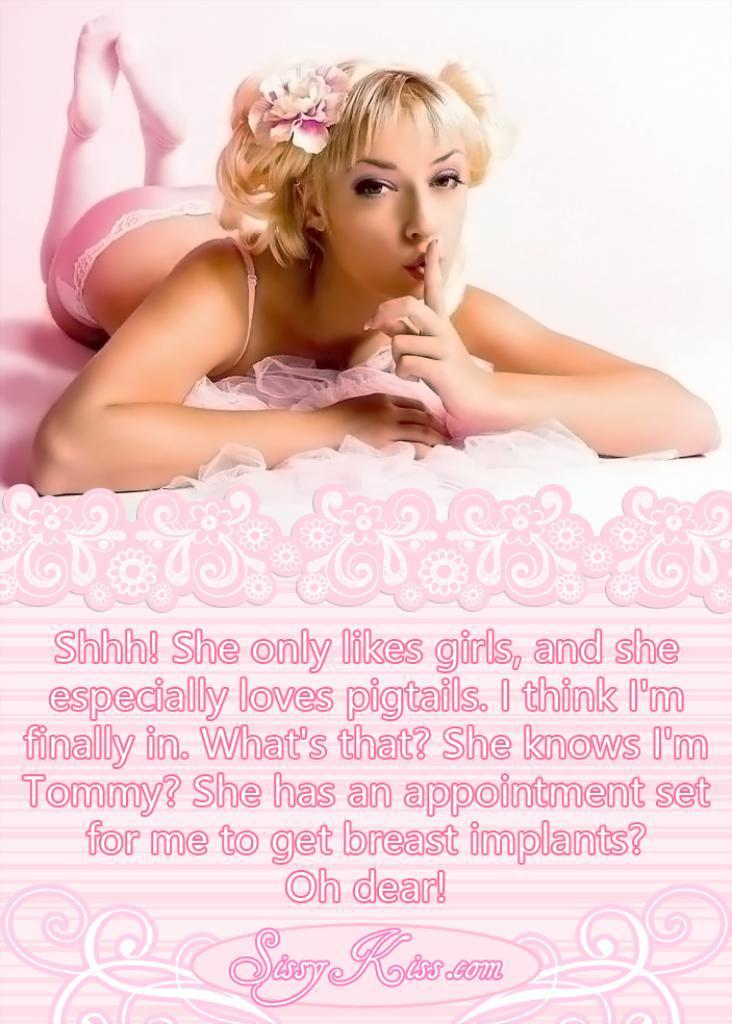Please provide a concise description of this image. In this image I can see a woman is lying on a surface. Here I can see something written on the image. 